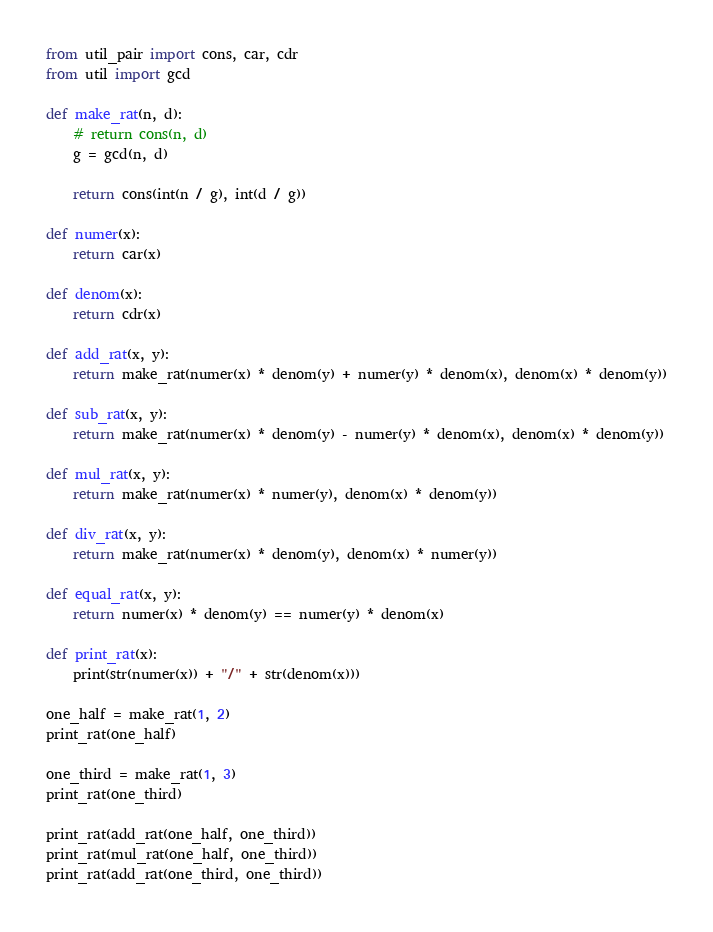Convert code to text. <code><loc_0><loc_0><loc_500><loc_500><_Python_>from util_pair import cons, car, cdr
from util import gcd

def make_rat(n, d):
    # return cons(n, d)
    g = gcd(n, d)
    
    return cons(int(n / g), int(d / g))

def numer(x):
    return car(x)

def denom(x):
    return cdr(x)

def add_rat(x, y):
    return make_rat(numer(x) * denom(y) + numer(y) * denom(x), denom(x) * denom(y))

def sub_rat(x, y):
    return make_rat(numer(x) * denom(y) - numer(y) * denom(x), denom(x) * denom(y))

def mul_rat(x, y):
    return make_rat(numer(x) * numer(y), denom(x) * denom(y))

def div_rat(x, y):
    return make_rat(numer(x) * denom(y), denom(x) * numer(y))

def equal_rat(x, y):
    return numer(x) * denom(y) == numer(y) * denom(x)

def print_rat(x):
    print(str(numer(x)) + "/" + str(denom(x)))

one_half = make_rat(1, 2)
print_rat(one_half)

one_third = make_rat(1, 3)
print_rat(one_third)

print_rat(add_rat(one_half, one_third))
print_rat(mul_rat(one_half, one_third))
print_rat(add_rat(one_third, one_third))</code> 